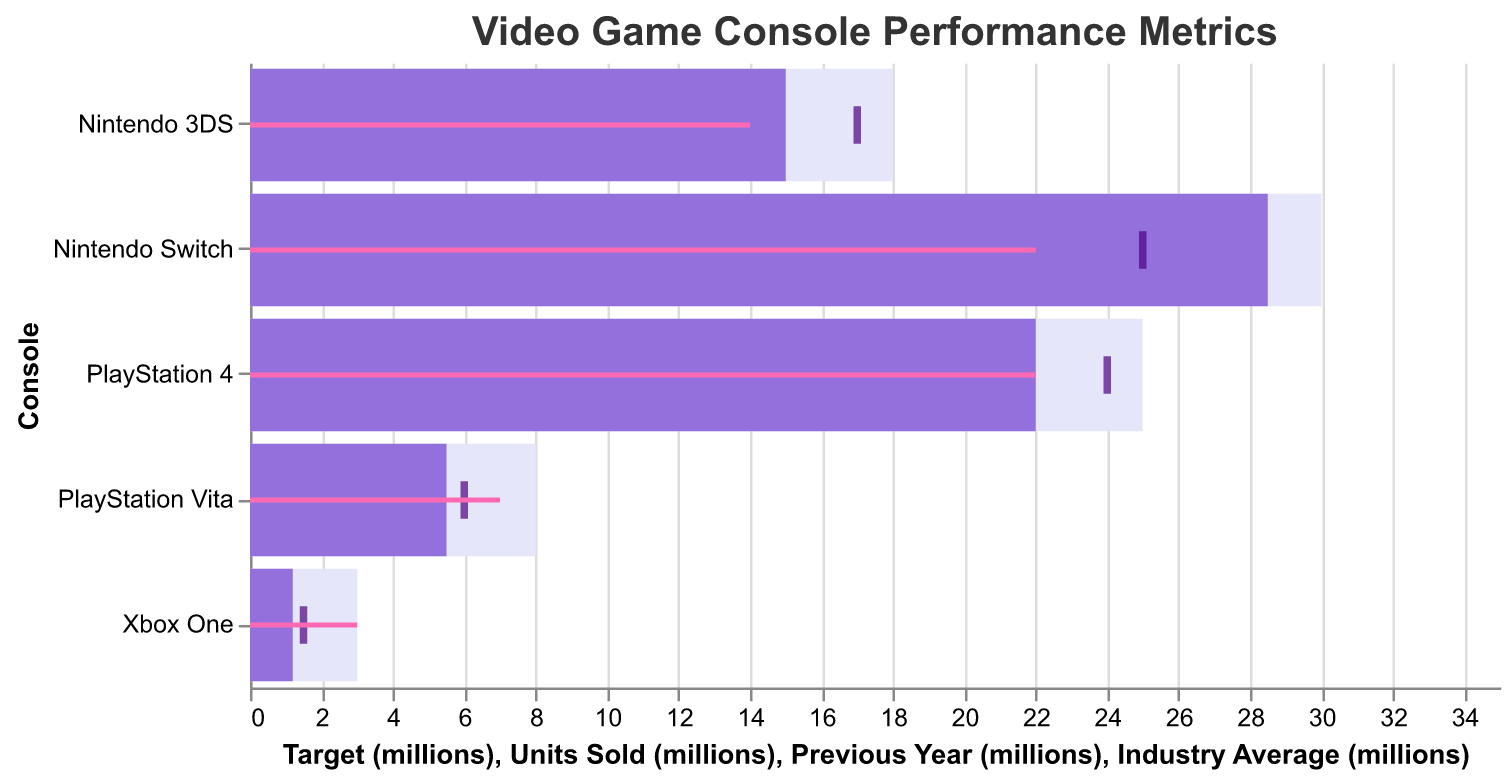What is the title of the chart? The title of the chart is located at the top and it clearly states "Video Game Console Performance Metrics".
Answer: Video Game Console Performance Metrics Which console has the highest units sold? By looking at the bars representing the units sold, the tallest bar corresponds to the Nintendo Switch, indicating it has the highest units sold.
Answer: Nintendo Switch What is the target for Xbox One in millions? The light-colored bar representing the target values shows that the target for Xbox One is at the 3 million mark.
Answer: 3 million How does PlayStation Vita’s previous year sales compare with its units sold this year? The tick mark for PlayStation Vita represents previous year sales at 6 million, whereas the dark bar shows current units sold at 5.5 million. This implies a decrease.
Answer: Decreased Which console's units sold is closest to its industry average? By comparing the length of the dark bars (units sold) with the location of the pink lines (industry average), we can see that the PlayStation 4's units sold (22 million) aligns exactly with its industry average (22 million).
Answer: PlayStation 4 What is the difference between Nintendo Switch’s target and units sold? The target for Nintendo Switch is 30 million, and its units sold are 28.5 million. The difference is 30 - 28.5 = 1.5 million.
Answer: 1.5 million Which console has the largest negative deviation from its target? By comparing the difference between target and units sold for each console: Nintendo Switch (1.5), PlayStation 4 (3), Nintendo 3DS (3), PlayStation Vita (2.5), Xbox One (1.8). The PlayStation Vita shows the largest negative deviation with 8 - 5.5 = 2.5 million.
Answer: PlayStation Vita For which console is the current units sold higher than the previous year’s sales? Comparing the dark bars with the tick marks for previous year sales, only the Nintendo Switch shows an increase, with 28.5 million units sold compared to 25 million in the previous year.
Answer: Nintendo Switch What's the average target value for all consoles? The target values for all consoles are: 30 + 25 + 18 + 8 + 3. Summing these up gives 84. Dividing by the number of consoles (5) gives an average target value of 84/5 = 16.8 million.
Answer: 16.8 million 